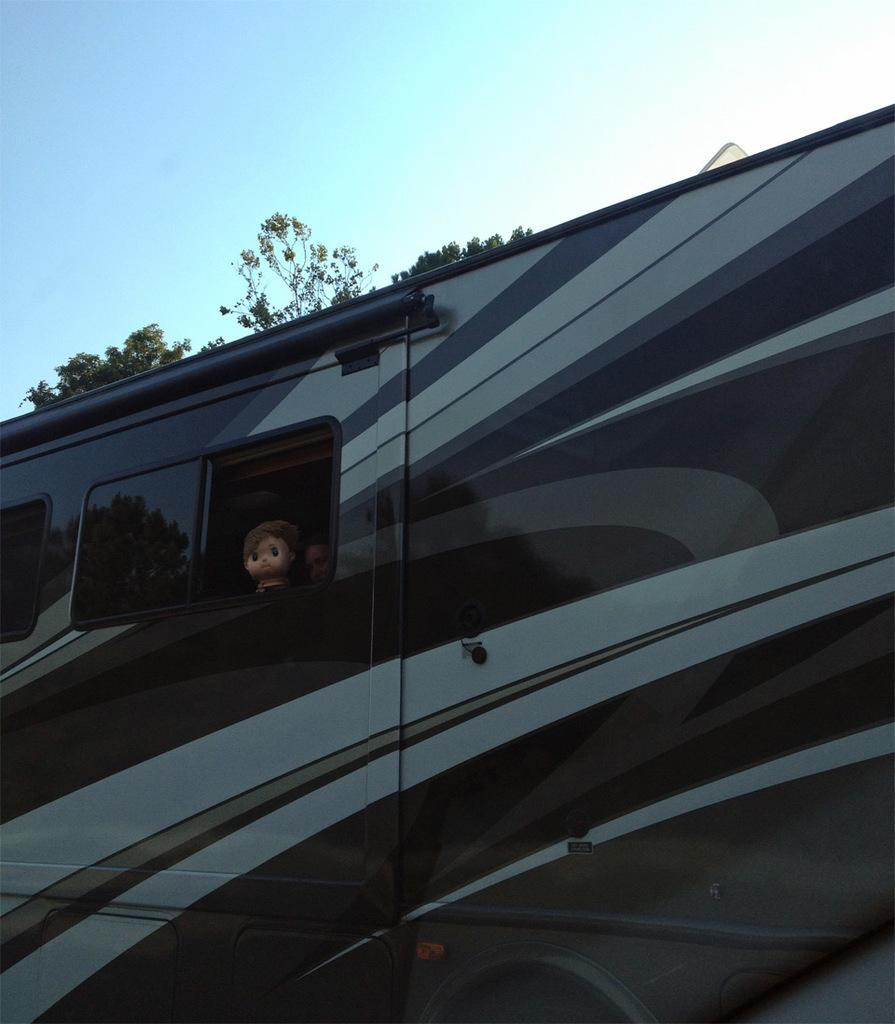What is there is a vehicle in the image, what can you tell me about it? The vehicle in the image has a window. What is visible through the window of the vehicle? There is a doll's face visible in the window of the vehicle. What type of natural environment can be seen in the image? There are trees in the image. How would you describe the weather based on the image? The sky is clear in the image, suggesting good weather. How many gloves can be seen hanging from the trees in the image? There are no gloves visible in the image; it only features a vehicle with a doll's face in the window, trees, and a clear sky. 